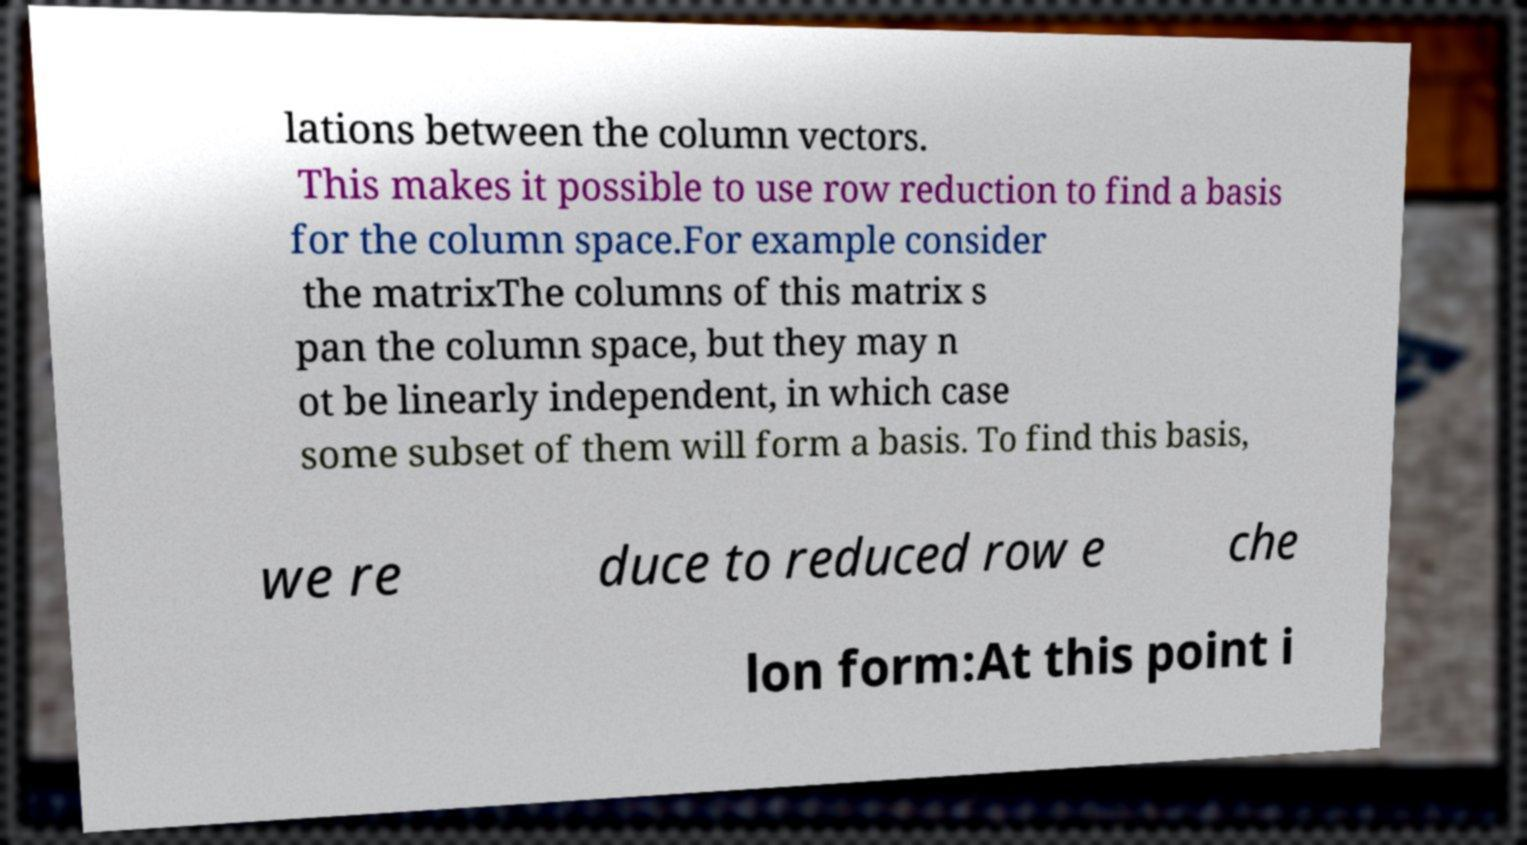For documentation purposes, I need the text within this image transcribed. Could you provide that? lations between the column vectors. This makes it possible to use row reduction to find a basis for the column space.For example consider the matrixThe columns of this matrix s pan the column space, but they may n ot be linearly independent, in which case some subset of them will form a basis. To find this basis, we re duce to reduced row e che lon form:At this point i 